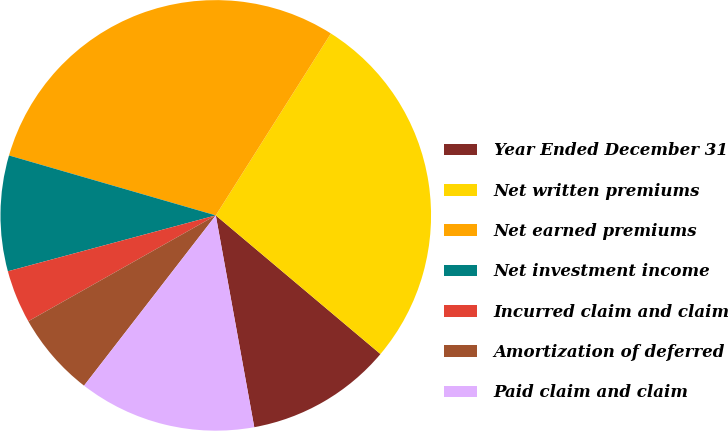Convert chart. <chart><loc_0><loc_0><loc_500><loc_500><pie_chart><fcel>Year Ended December 31<fcel>Net written premiums<fcel>Net earned premiums<fcel>Net investment income<fcel>Incurred claim and claim<fcel>Amortization of deferred<fcel>Paid claim and claim<nl><fcel>11.0%<fcel>27.16%<fcel>29.49%<fcel>8.67%<fcel>4.0%<fcel>6.34%<fcel>13.34%<nl></chart> 